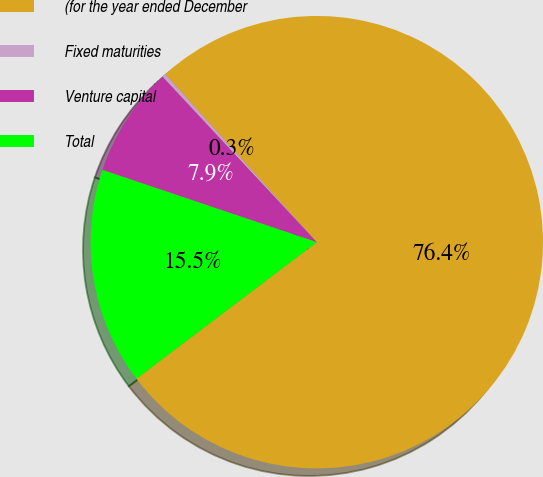Convert chart. <chart><loc_0><loc_0><loc_500><loc_500><pie_chart><fcel>(for the year ended December<fcel>Fixed maturities<fcel>Venture capital<fcel>Total<nl><fcel>76.37%<fcel>0.27%<fcel>7.88%<fcel>15.49%<nl></chart> 